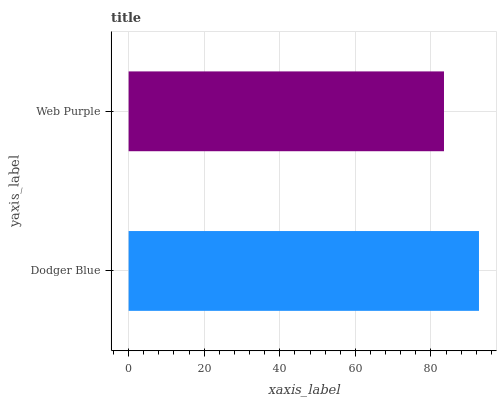Is Web Purple the minimum?
Answer yes or no. Yes. Is Dodger Blue the maximum?
Answer yes or no. Yes. Is Web Purple the maximum?
Answer yes or no. No. Is Dodger Blue greater than Web Purple?
Answer yes or no. Yes. Is Web Purple less than Dodger Blue?
Answer yes or no. Yes. Is Web Purple greater than Dodger Blue?
Answer yes or no. No. Is Dodger Blue less than Web Purple?
Answer yes or no. No. Is Dodger Blue the high median?
Answer yes or no. Yes. Is Web Purple the low median?
Answer yes or no. Yes. Is Web Purple the high median?
Answer yes or no. No. Is Dodger Blue the low median?
Answer yes or no. No. 